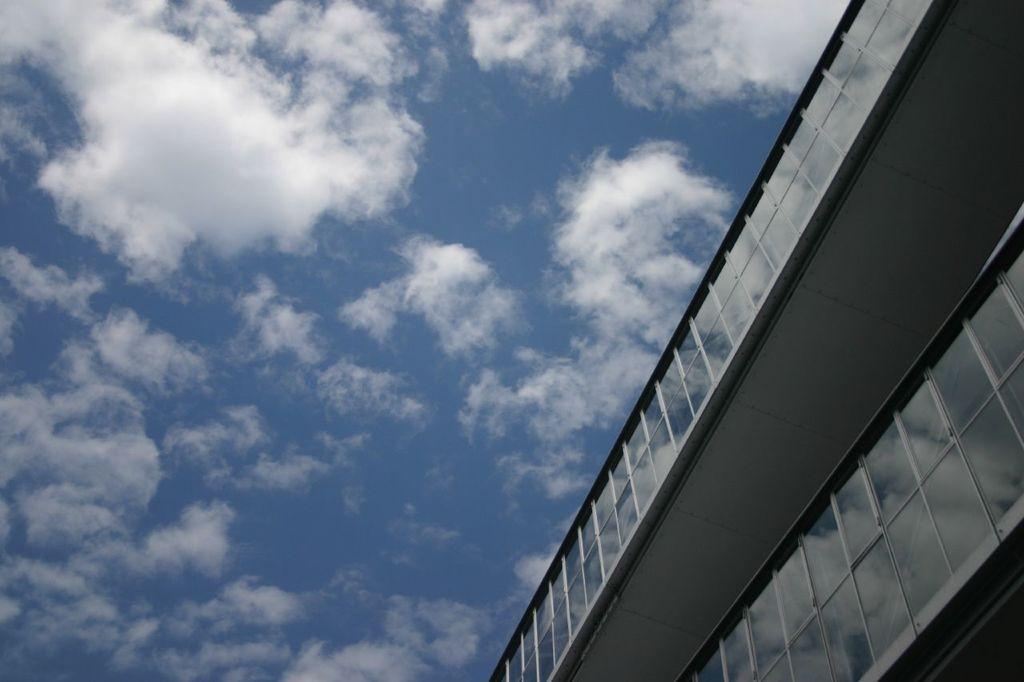Could you give a brief overview of what you see in this image? In this picture we can see building and glass windows. In the background of the image we can see the sky with clouds. 